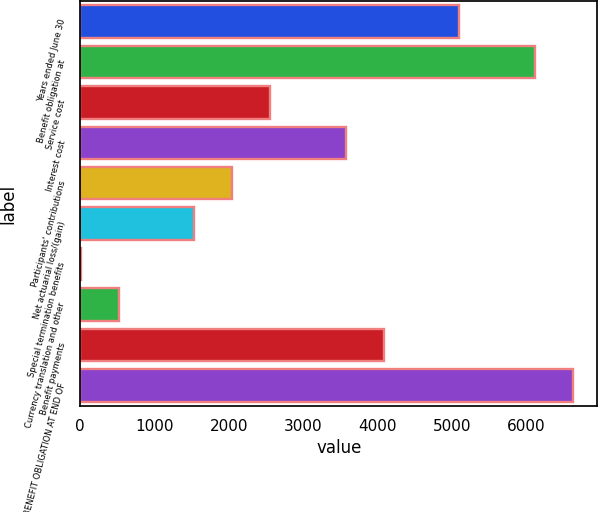<chart> <loc_0><loc_0><loc_500><loc_500><bar_chart><fcel>Years ended June 30<fcel>Benefit obligation at<fcel>Service cost<fcel>Interest cost<fcel>Participants' contributions<fcel>Net actuarial loss/(gain)<fcel>Special termination benefits<fcel>Currency translation and other<fcel>Benefit payments<fcel>BENEFIT OBLIGATION AT END OF<nl><fcel>5096<fcel>6113.6<fcel>2552<fcel>3569.6<fcel>2043.2<fcel>1534.4<fcel>8<fcel>516.8<fcel>4078.4<fcel>6622.4<nl></chart> 